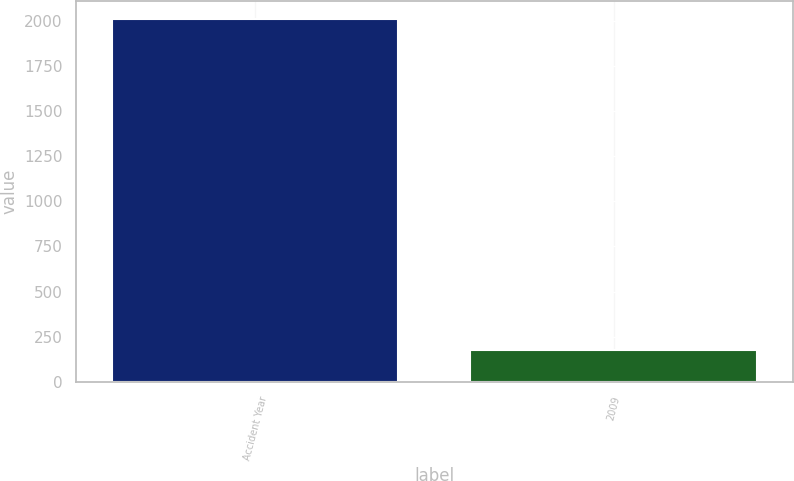Convert chart. <chart><loc_0><loc_0><loc_500><loc_500><bar_chart><fcel>Accident Year<fcel>2009<nl><fcel>2009<fcel>179<nl></chart> 